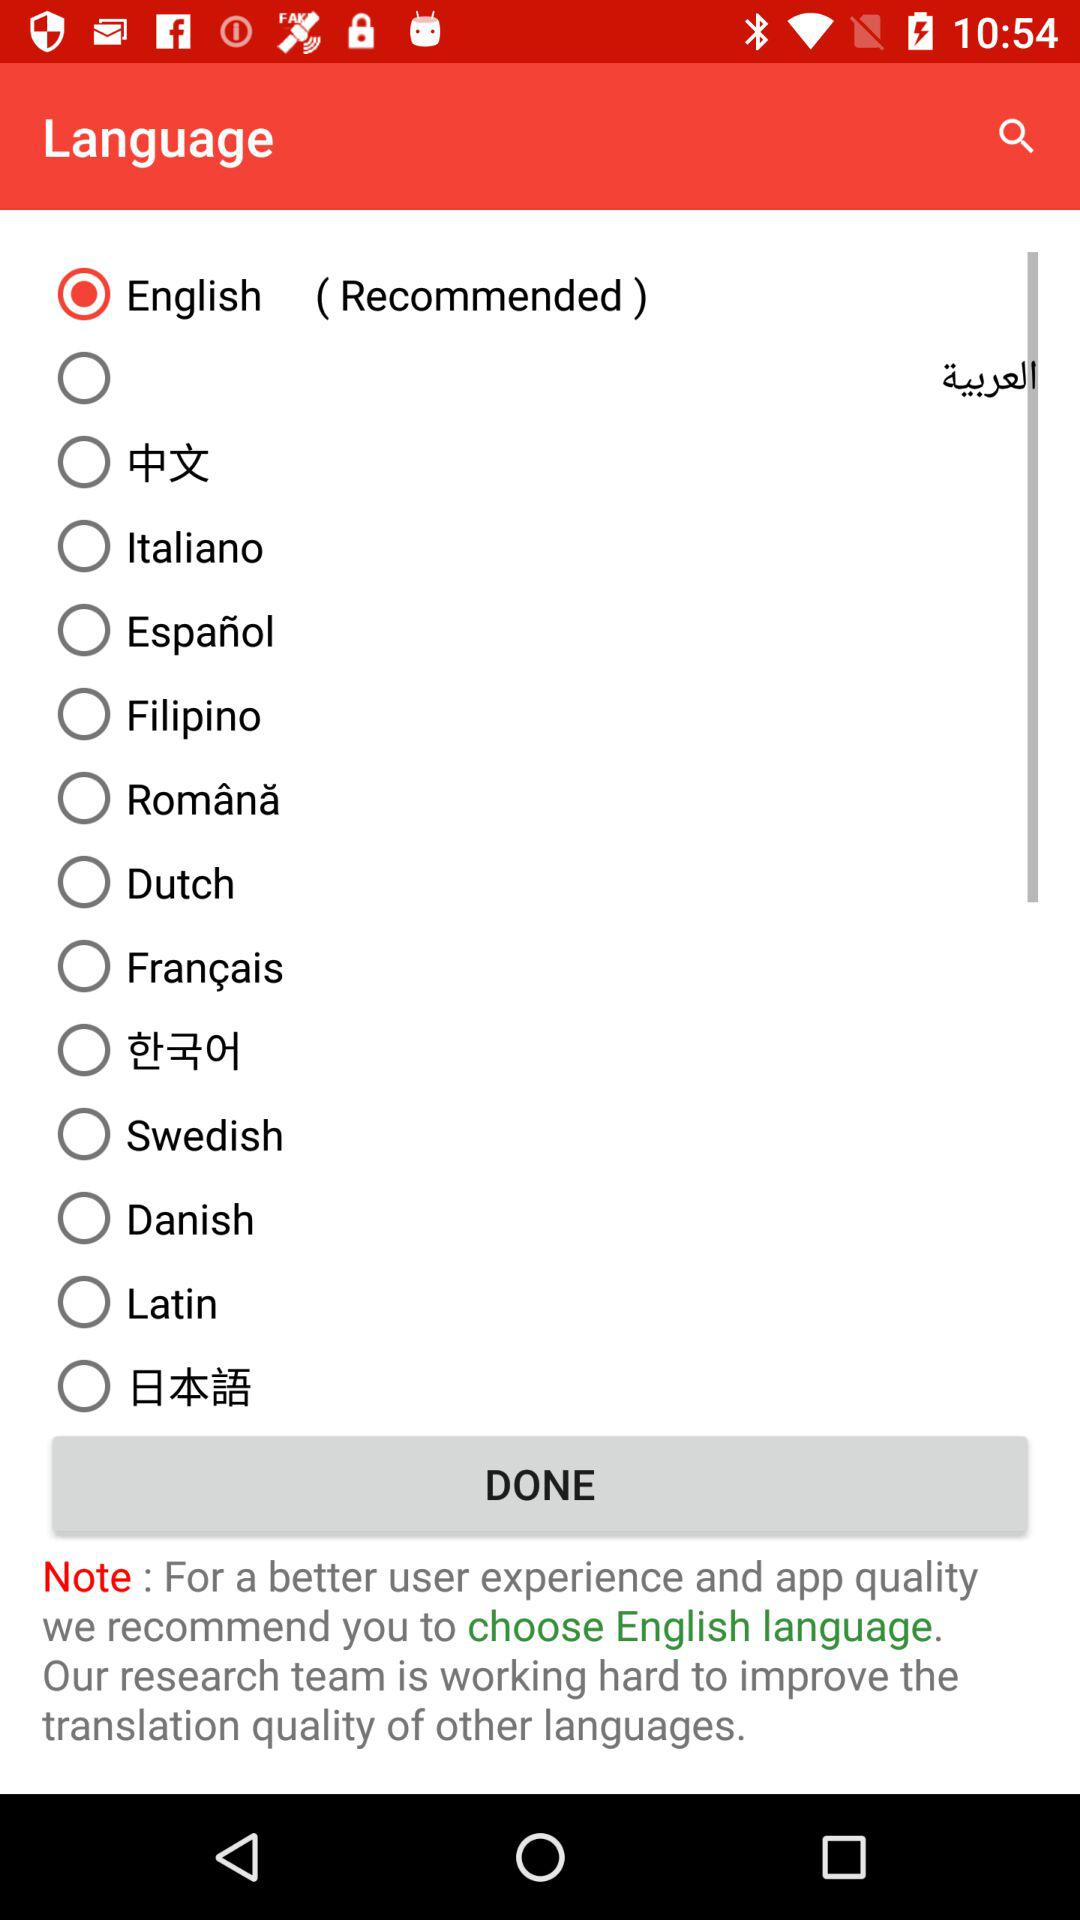How many languages are available in this app?
Answer the question using a single word or phrase. 14 